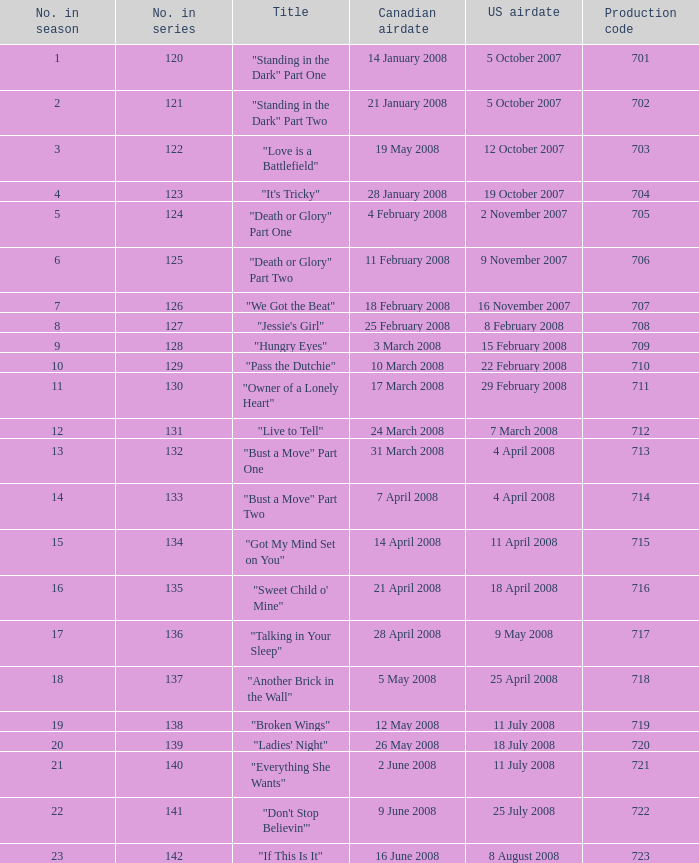The U.S. airdate of 4 april 2008 had a production code of what? 714.0. 